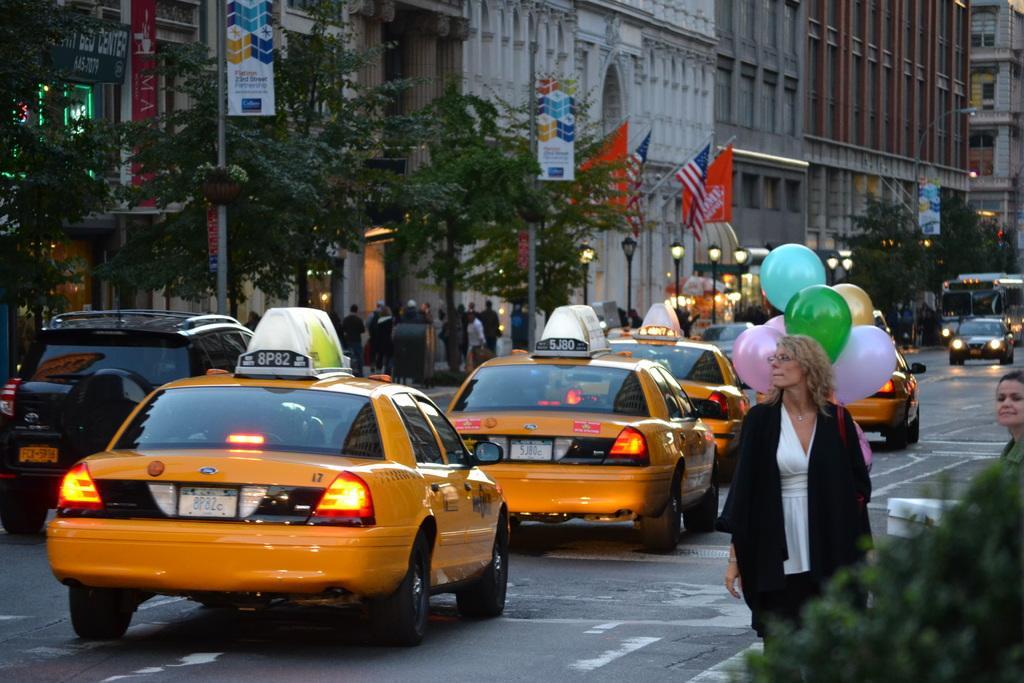Please provide a concise description of this image. In this image we can see vehicles on the road. Also there are many people. There are balloons. In the back we can see buildings, trees. Also there are flags. And there are banners on poles. Also there are lights. 